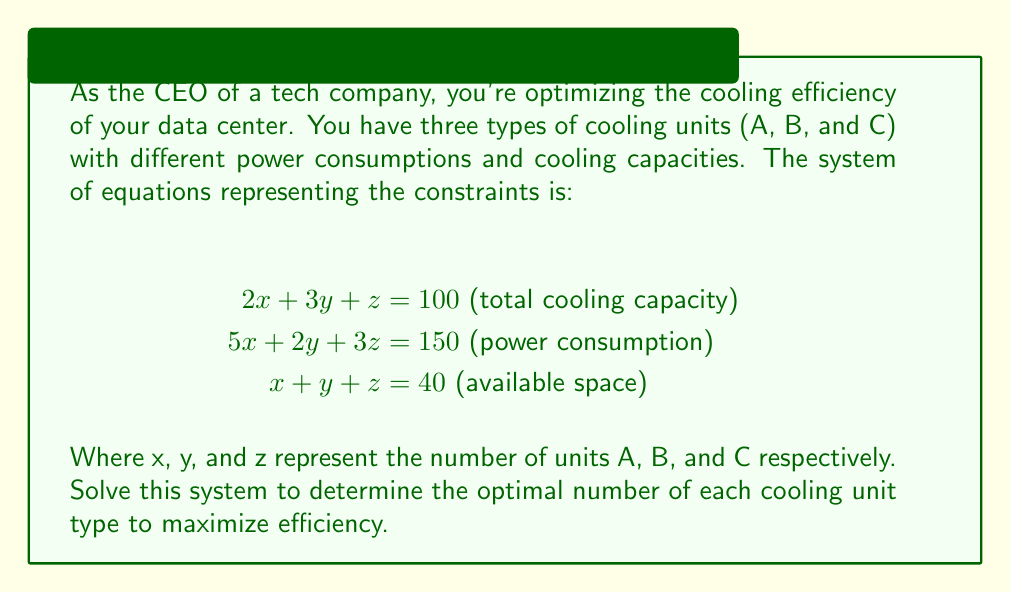Solve this math problem. To solve this system of linear equations, we'll use the Gaussian elimination method:

1) First, let's write the augmented matrix:

$$\begin{bmatrix}
2 & 3 & 1 & 100 \\
5 & 2 & 3 & 150 \\
1 & 1 & 1 & 40
\end{bmatrix}$$

2) Multiply the first row by -5/2 and add it to the second row:

$$\begin{bmatrix}
2 & 3 & 1 & 100 \\
0 & -5.5 & 0.5 & -100 \\
1 & 1 & 1 & 40
\end{bmatrix}$$

3) Multiply the first row by -1/2 and add it to the third row:

$$\begin{bmatrix}
2 & 3 & 1 & 100 \\
0 & -5.5 & 0.5 & -100 \\
0 & -0.5 & 0.5 & -10
\end{bmatrix}$$

4) Multiply the second row by 1/11 and the third row by 2:

$$\begin{bmatrix}
2 & 3 & 1 & 100 \\
0 & 1 & -\frac{1}{11} & \frac{200}{11} \\
0 & -1 & 1 & -20
\end{bmatrix}$$

5) Add the third row to the second row:

$$\begin{bmatrix}
2 & 3 & 1 & 100 \\
0 & 1 & \frac{10}{11} & \frac{20}{11} \\
0 & -1 & 1 & -20
\end{bmatrix}$$

6) Multiply the second row by 3 and subtract from the first row:

$$\begin{bmatrix}
2 & 0 & -\frac{2}{11} & \frac{940}{11} \\
0 & 1 & \frac{10}{11} & \frac{20}{11} \\
0 & -1 & 1 & -20
\end{bmatrix}$$

7) Add the second row to the third row:

$$\begin{bmatrix}
2 & 0 & -\frac{2}{11} & \frac{940}{11} \\
0 & 1 & \frac{10}{11} & \frac{20}{11} \\
0 & 0 & \frac{21}{11} & -\frac{200}{11}
\end{bmatrix}$$

8) Now we have an upper triangular matrix. We can solve for z:

$z = \frac{-200/11}{21/11} = -\frac{200}{21}$

9) Substitute z in the second equation to solve for y:

$y + \frac{10}{11}(-\frac{200}{21}) = \frac{20}{11}$
$y = \frac{20}{11} + \frac{2000}{231} = \frac{620}{231}$

10) Substitute y and z in the first equation to solve for x:

$2x - \frac{2}{11}(-\frac{200}{21}) = \frac{940}{11}$
$2x = \frac{940}{11} - \frac{400}{231} = \frac{20020}{231}$
$x = \frac{10010}{231}$

Therefore, the solution is:
$x = \frac{10010}{231} \approx 43.33$
$y = \frac{620}{231} \approx 2.68$
$z = -\frac{200}{21} \approx -9.52$

However, since we can't have negative or fractional cooling units, we need to round to the nearest whole number:
x = 43, y = 3, z = 0
Answer: 43 units of type A, 3 units of type B, 0 units of type C 